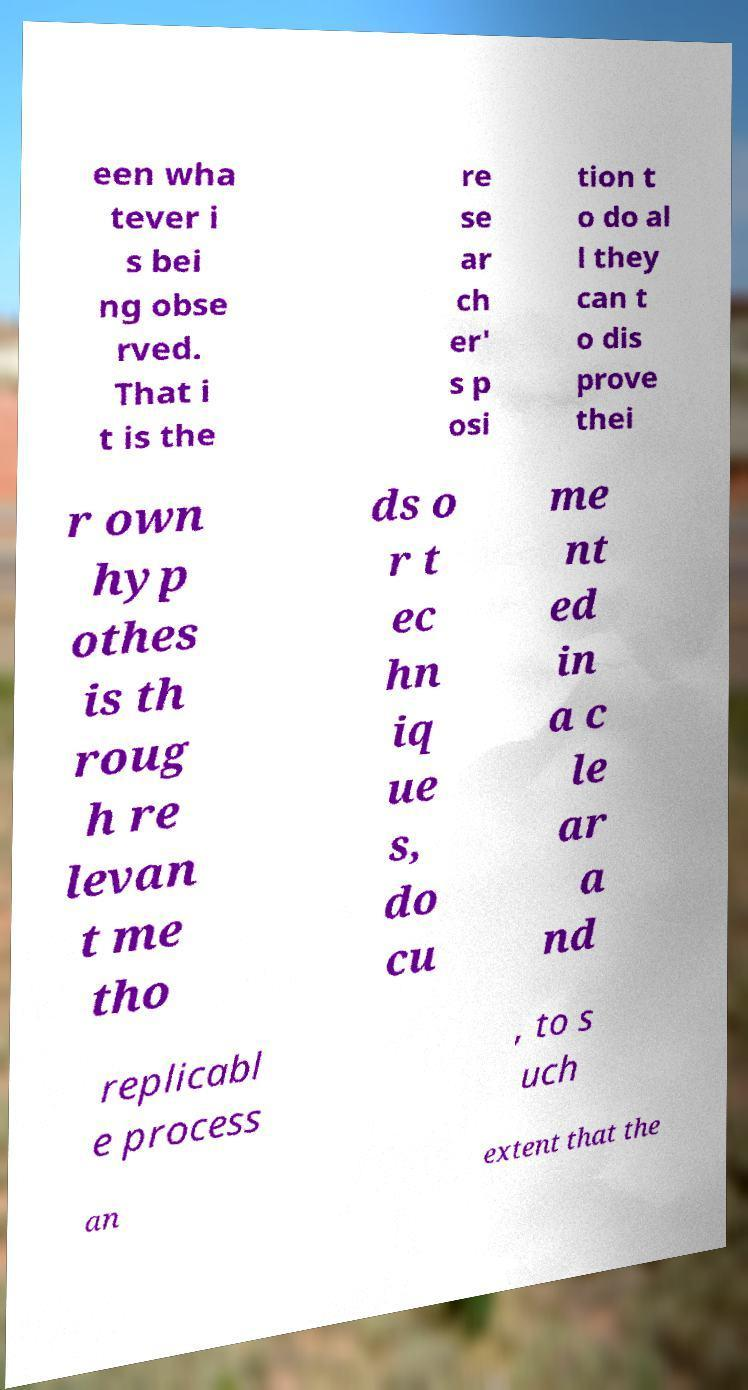Please identify and transcribe the text found in this image. een wha tever i s bei ng obse rved. That i t is the re se ar ch er' s p osi tion t o do al l they can t o dis prove thei r own hyp othes is th roug h re levan t me tho ds o r t ec hn iq ue s, do cu me nt ed in a c le ar a nd replicabl e process , to s uch an extent that the 